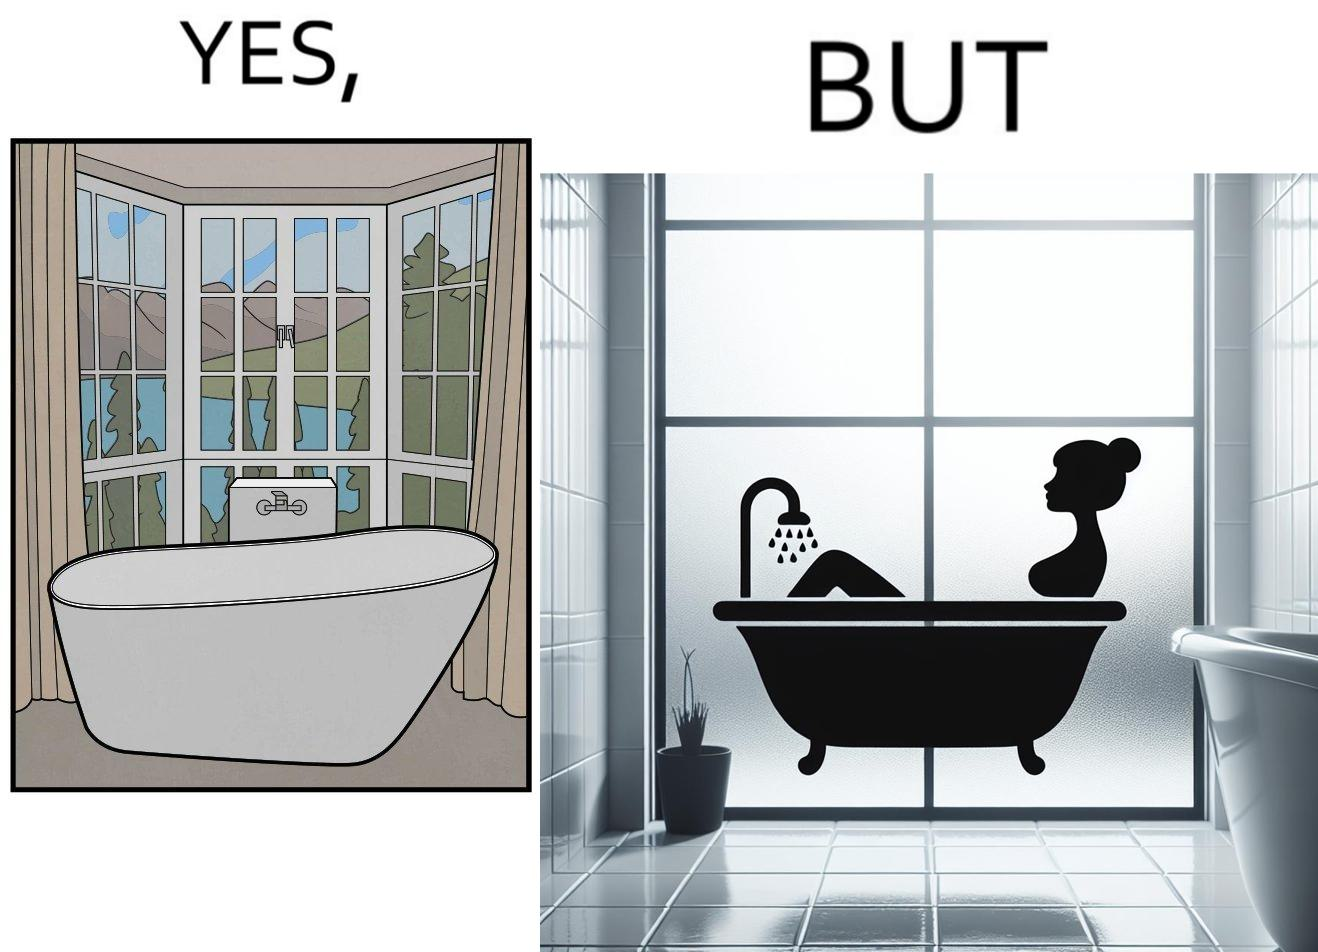Describe the contrast between the left and right parts of this image. In the left part of the image: a bathtub by the side of a window which has a very scenic view of lake and mountains. In the right part of the image: a woman bathing in a bathtub, while the window glasses are foggy from the steam of the hot water. 